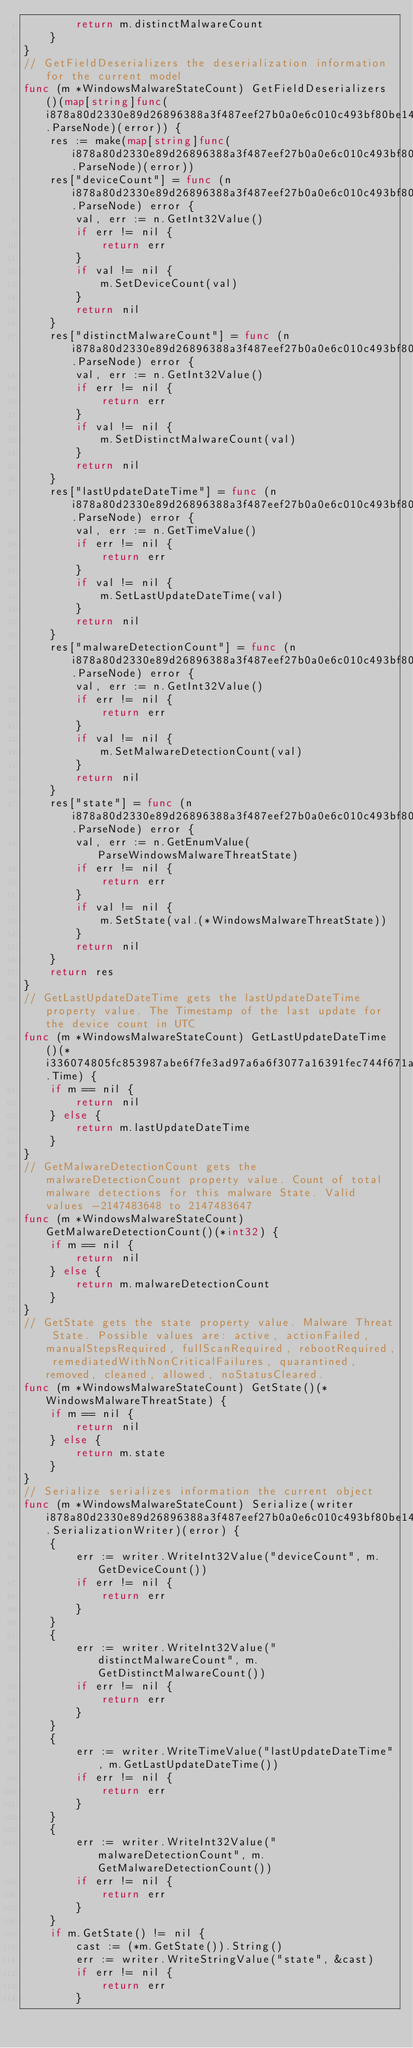<code> <loc_0><loc_0><loc_500><loc_500><_Go_>        return m.distinctMalwareCount
    }
}
// GetFieldDeserializers the deserialization information for the current model
func (m *WindowsMalwareStateCount) GetFieldDeserializers()(map[string]func(i878a80d2330e89d26896388a3f487eef27b0a0e6c010c493bf80be1452208f91.ParseNode)(error)) {
    res := make(map[string]func(i878a80d2330e89d26896388a3f487eef27b0a0e6c010c493bf80be1452208f91.ParseNode)(error))
    res["deviceCount"] = func (n i878a80d2330e89d26896388a3f487eef27b0a0e6c010c493bf80be1452208f91.ParseNode) error {
        val, err := n.GetInt32Value()
        if err != nil {
            return err
        }
        if val != nil {
            m.SetDeviceCount(val)
        }
        return nil
    }
    res["distinctMalwareCount"] = func (n i878a80d2330e89d26896388a3f487eef27b0a0e6c010c493bf80be1452208f91.ParseNode) error {
        val, err := n.GetInt32Value()
        if err != nil {
            return err
        }
        if val != nil {
            m.SetDistinctMalwareCount(val)
        }
        return nil
    }
    res["lastUpdateDateTime"] = func (n i878a80d2330e89d26896388a3f487eef27b0a0e6c010c493bf80be1452208f91.ParseNode) error {
        val, err := n.GetTimeValue()
        if err != nil {
            return err
        }
        if val != nil {
            m.SetLastUpdateDateTime(val)
        }
        return nil
    }
    res["malwareDetectionCount"] = func (n i878a80d2330e89d26896388a3f487eef27b0a0e6c010c493bf80be1452208f91.ParseNode) error {
        val, err := n.GetInt32Value()
        if err != nil {
            return err
        }
        if val != nil {
            m.SetMalwareDetectionCount(val)
        }
        return nil
    }
    res["state"] = func (n i878a80d2330e89d26896388a3f487eef27b0a0e6c010c493bf80be1452208f91.ParseNode) error {
        val, err := n.GetEnumValue(ParseWindowsMalwareThreatState)
        if err != nil {
            return err
        }
        if val != nil {
            m.SetState(val.(*WindowsMalwareThreatState))
        }
        return nil
    }
    return res
}
// GetLastUpdateDateTime gets the lastUpdateDateTime property value. The Timestamp of the last update for the device count in UTC
func (m *WindowsMalwareStateCount) GetLastUpdateDateTime()(*i336074805fc853987abe6f7fe3ad97a6a6f3077a16391fec744f671a015fbd7e.Time) {
    if m == nil {
        return nil
    } else {
        return m.lastUpdateDateTime
    }
}
// GetMalwareDetectionCount gets the malwareDetectionCount property value. Count of total malware detections for this malware State. Valid values -2147483648 to 2147483647
func (m *WindowsMalwareStateCount) GetMalwareDetectionCount()(*int32) {
    if m == nil {
        return nil
    } else {
        return m.malwareDetectionCount
    }
}
// GetState gets the state property value. Malware Threat State. Possible values are: active, actionFailed, manualStepsRequired, fullScanRequired, rebootRequired, remediatedWithNonCriticalFailures, quarantined, removed, cleaned, allowed, noStatusCleared.
func (m *WindowsMalwareStateCount) GetState()(*WindowsMalwareThreatState) {
    if m == nil {
        return nil
    } else {
        return m.state
    }
}
// Serialize serializes information the current object
func (m *WindowsMalwareStateCount) Serialize(writer i878a80d2330e89d26896388a3f487eef27b0a0e6c010c493bf80be1452208f91.SerializationWriter)(error) {
    {
        err := writer.WriteInt32Value("deviceCount", m.GetDeviceCount())
        if err != nil {
            return err
        }
    }
    {
        err := writer.WriteInt32Value("distinctMalwareCount", m.GetDistinctMalwareCount())
        if err != nil {
            return err
        }
    }
    {
        err := writer.WriteTimeValue("lastUpdateDateTime", m.GetLastUpdateDateTime())
        if err != nil {
            return err
        }
    }
    {
        err := writer.WriteInt32Value("malwareDetectionCount", m.GetMalwareDetectionCount())
        if err != nil {
            return err
        }
    }
    if m.GetState() != nil {
        cast := (*m.GetState()).String()
        err := writer.WriteStringValue("state", &cast)
        if err != nil {
            return err
        }</code> 